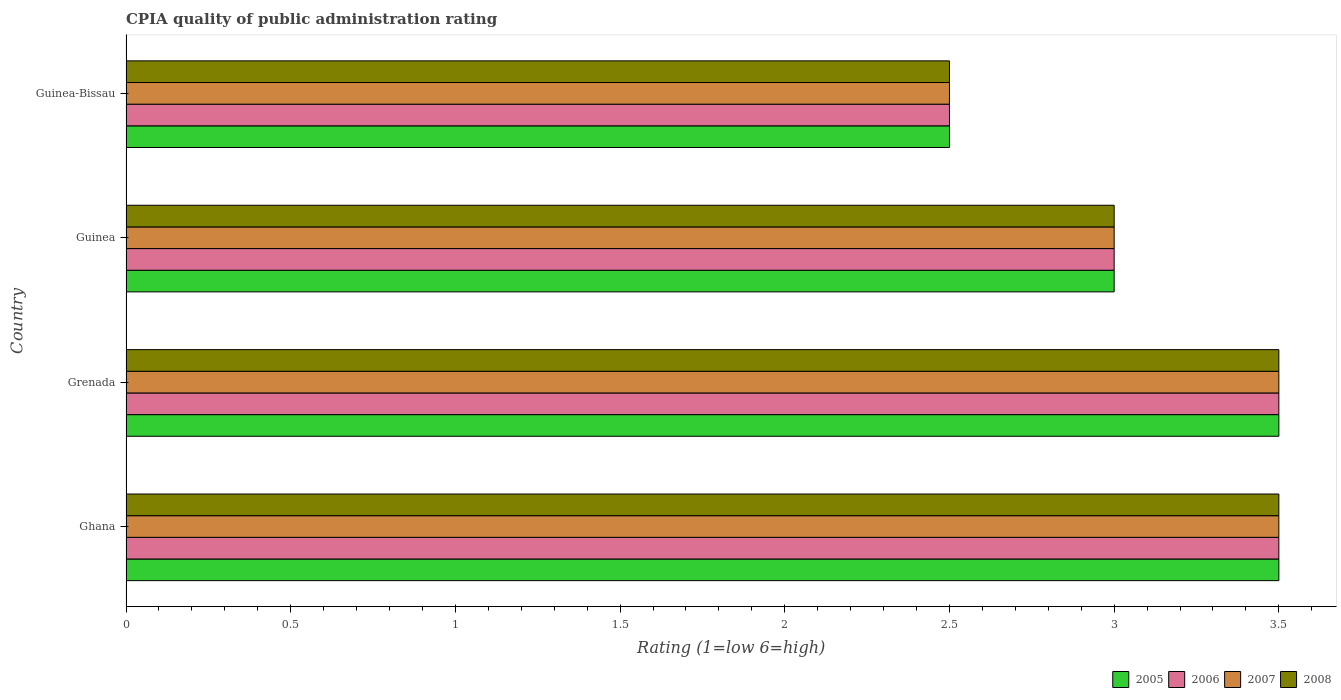How many different coloured bars are there?
Keep it short and to the point. 4. How many bars are there on the 3rd tick from the top?
Your response must be concise. 4. How many bars are there on the 2nd tick from the bottom?
Provide a short and direct response. 4. What is the label of the 1st group of bars from the top?
Ensure brevity in your answer.  Guinea-Bissau. In how many cases, is the number of bars for a given country not equal to the number of legend labels?
Your response must be concise. 0. Across all countries, what is the minimum CPIA rating in 2005?
Provide a short and direct response. 2.5. In which country was the CPIA rating in 2006 minimum?
Offer a terse response. Guinea-Bissau. What is the difference between the CPIA rating in 2005 in Guinea-Bissau and the CPIA rating in 2007 in Grenada?
Offer a terse response. -1. What is the average CPIA rating in 2005 per country?
Give a very brief answer. 3.12. What is the ratio of the CPIA rating in 2006 in Ghana to that in Guinea?
Your response must be concise. 1.17. Is the difference between the CPIA rating in 2007 in Ghana and Grenada greater than the difference between the CPIA rating in 2006 in Ghana and Grenada?
Offer a very short reply. No. What is the difference between the highest and the second highest CPIA rating in 2005?
Give a very brief answer. 0. What is the difference between the highest and the lowest CPIA rating in 2008?
Provide a succinct answer. 1. In how many countries, is the CPIA rating in 2008 greater than the average CPIA rating in 2008 taken over all countries?
Ensure brevity in your answer.  2. Is the sum of the CPIA rating in 2007 in Grenada and Guinea greater than the maximum CPIA rating in 2006 across all countries?
Give a very brief answer. Yes. Is it the case that in every country, the sum of the CPIA rating in 2008 and CPIA rating in 2007 is greater than the sum of CPIA rating in 2006 and CPIA rating in 2005?
Your response must be concise. No. What does the 2nd bar from the top in Guinea represents?
Your answer should be compact. 2007. How many bars are there?
Provide a short and direct response. 16. Are all the bars in the graph horizontal?
Ensure brevity in your answer.  Yes. Are the values on the major ticks of X-axis written in scientific E-notation?
Offer a terse response. No. Does the graph contain grids?
Your response must be concise. No. Where does the legend appear in the graph?
Your response must be concise. Bottom right. How are the legend labels stacked?
Your response must be concise. Horizontal. What is the title of the graph?
Ensure brevity in your answer.  CPIA quality of public administration rating. What is the Rating (1=low 6=high) in 2005 in Ghana?
Ensure brevity in your answer.  3.5. What is the Rating (1=low 6=high) in 2006 in Ghana?
Your response must be concise. 3.5. What is the Rating (1=low 6=high) of 2008 in Ghana?
Your answer should be compact. 3.5. What is the Rating (1=low 6=high) in 2005 in Grenada?
Give a very brief answer. 3.5. What is the Rating (1=low 6=high) of 2006 in Grenada?
Offer a terse response. 3.5. What is the Rating (1=low 6=high) in 2006 in Guinea?
Make the answer very short. 3. What is the Rating (1=low 6=high) in 2007 in Guinea?
Your answer should be compact. 3. What is the Rating (1=low 6=high) in 2008 in Guinea?
Your answer should be very brief. 3. What is the Rating (1=low 6=high) of 2005 in Guinea-Bissau?
Ensure brevity in your answer.  2.5. What is the Rating (1=low 6=high) in 2006 in Guinea-Bissau?
Keep it short and to the point. 2.5. What is the Rating (1=low 6=high) of 2007 in Guinea-Bissau?
Offer a terse response. 2.5. Across all countries, what is the maximum Rating (1=low 6=high) of 2005?
Your response must be concise. 3.5. Across all countries, what is the maximum Rating (1=low 6=high) in 2006?
Ensure brevity in your answer.  3.5. Across all countries, what is the maximum Rating (1=low 6=high) in 2008?
Make the answer very short. 3.5. Across all countries, what is the minimum Rating (1=low 6=high) of 2006?
Your answer should be very brief. 2.5. What is the total Rating (1=low 6=high) of 2006 in the graph?
Your response must be concise. 12.5. What is the total Rating (1=low 6=high) of 2008 in the graph?
Offer a terse response. 12.5. What is the difference between the Rating (1=low 6=high) in 2008 in Ghana and that in Grenada?
Keep it short and to the point. 0. What is the difference between the Rating (1=low 6=high) in 2005 in Ghana and that in Guinea?
Your response must be concise. 0.5. What is the difference between the Rating (1=low 6=high) in 2006 in Ghana and that in Guinea?
Make the answer very short. 0.5. What is the difference between the Rating (1=low 6=high) in 2008 in Ghana and that in Guinea?
Provide a short and direct response. 0.5. What is the difference between the Rating (1=low 6=high) of 2006 in Ghana and that in Guinea-Bissau?
Ensure brevity in your answer.  1. What is the difference between the Rating (1=low 6=high) in 2007 in Ghana and that in Guinea-Bissau?
Give a very brief answer. 1. What is the difference between the Rating (1=low 6=high) of 2006 in Grenada and that in Guinea?
Offer a very short reply. 0.5. What is the difference between the Rating (1=low 6=high) of 2005 in Grenada and that in Guinea-Bissau?
Provide a succinct answer. 1. What is the difference between the Rating (1=low 6=high) of 2006 in Grenada and that in Guinea-Bissau?
Provide a succinct answer. 1. What is the difference between the Rating (1=low 6=high) in 2008 in Grenada and that in Guinea-Bissau?
Provide a succinct answer. 1. What is the difference between the Rating (1=low 6=high) of 2005 in Guinea and that in Guinea-Bissau?
Your response must be concise. 0.5. What is the difference between the Rating (1=low 6=high) in 2007 in Guinea and that in Guinea-Bissau?
Offer a terse response. 0.5. What is the difference between the Rating (1=low 6=high) in 2008 in Guinea and that in Guinea-Bissau?
Offer a terse response. 0.5. What is the difference between the Rating (1=low 6=high) in 2005 in Ghana and the Rating (1=low 6=high) in 2006 in Grenada?
Provide a short and direct response. 0. What is the difference between the Rating (1=low 6=high) in 2005 in Ghana and the Rating (1=low 6=high) in 2007 in Grenada?
Make the answer very short. 0. What is the difference between the Rating (1=low 6=high) in 2005 in Ghana and the Rating (1=low 6=high) in 2008 in Grenada?
Give a very brief answer. 0. What is the difference between the Rating (1=low 6=high) in 2006 in Ghana and the Rating (1=low 6=high) in 2008 in Grenada?
Make the answer very short. 0. What is the difference between the Rating (1=low 6=high) in 2005 in Ghana and the Rating (1=low 6=high) in 2008 in Guinea-Bissau?
Make the answer very short. 1. What is the difference between the Rating (1=low 6=high) of 2005 in Grenada and the Rating (1=low 6=high) of 2006 in Guinea?
Offer a very short reply. 0.5. What is the difference between the Rating (1=low 6=high) in 2005 in Grenada and the Rating (1=low 6=high) in 2007 in Guinea?
Ensure brevity in your answer.  0.5. What is the difference between the Rating (1=low 6=high) of 2005 in Grenada and the Rating (1=low 6=high) of 2008 in Guinea?
Give a very brief answer. 0.5. What is the difference between the Rating (1=low 6=high) in 2006 in Grenada and the Rating (1=low 6=high) in 2007 in Guinea?
Provide a short and direct response. 0.5. What is the difference between the Rating (1=low 6=high) of 2005 in Grenada and the Rating (1=low 6=high) of 2006 in Guinea-Bissau?
Your answer should be compact. 1. What is the difference between the Rating (1=low 6=high) in 2005 in Grenada and the Rating (1=low 6=high) in 2007 in Guinea-Bissau?
Provide a short and direct response. 1. What is the difference between the Rating (1=low 6=high) of 2006 in Grenada and the Rating (1=low 6=high) of 2007 in Guinea-Bissau?
Keep it short and to the point. 1. What is the difference between the Rating (1=low 6=high) of 2005 in Guinea and the Rating (1=low 6=high) of 2007 in Guinea-Bissau?
Your answer should be compact. 0.5. What is the difference between the Rating (1=low 6=high) of 2005 in Guinea and the Rating (1=low 6=high) of 2008 in Guinea-Bissau?
Ensure brevity in your answer.  0.5. What is the difference between the Rating (1=low 6=high) of 2006 in Guinea and the Rating (1=low 6=high) of 2007 in Guinea-Bissau?
Ensure brevity in your answer.  0.5. What is the difference between the Rating (1=low 6=high) of 2007 in Guinea and the Rating (1=low 6=high) of 2008 in Guinea-Bissau?
Provide a short and direct response. 0.5. What is the average Rating (1=low 6=high) of 2005 per country?
Provide a succinct answer. 3.12. What is the average Rating (1=low 6=high) in 2006 per country?
Keep it short and to the point. 3.12. What is the average Rating (1=low 6=high) in 2007 per country?
Your answer should be very brief. 3.12. What is the average Rating (1=low 6=high) in 2008 per country?
Offer a very short reply. 3.12. What is the difference between the Rating (1=low 6=high) in 2005 and Rating (1=low 6=high) in 2006 in Ghana?
Your answer should be very brief. 0. What is the difference between the Rating (1=low 6=high) in 2006 and Rating (1=low 6=high) in 2007 in Ghana?
Offer a terse response. 0. What is the difference between the Rating (1=low 6=high) in 2006 and Rating (1=low 6=high) in 2008 in Ghana?
Your response must be concise. 0. What is the difference between the Rating (1=low 6=high) in 2005 and Rating (1=low 6=high) in 2007 in Grenada?
Your answer should be compact. 0. What is the difference between the Rating (1=low 6=high) of 2005 and Rating (1=low 6=high) of 2008 in Grenada?
Keep it short and to the point. 0. What is the difference between the Rating (1=low 6=high) of 2006 and Rating (1=low 6=high) of 2007 in Grenada?
Your response must be concise. 0. What is the difference between the Rating (1=low 6=high) of 2005 and Rating (1=low 6=high) of 2006 in Guinea?
Your response must be concise. 0. What is the difference between the Rating (1=low 6=high) of 2005 and Rating (1=low 6=high) of 2007 in Guinea?
Make the answer very short. 0. What is the difference between the Rating (1=low 6=high) in 2005 and Rating (1=low 6=high) in 2008 in Guinea?
Keep it short and to the point. 0. What is the difference between the Rating (1=low 6=high) in 2005 and Rating (1=low 6=high) in 2007 in Guinea-Bissau?
Provide a succinct answer. 0. What is the difference between the Rating (1=low 6=high) of 2006 and Rating (1=low 6=high) of 2008 in Guinea-Bissau?
Keep it short and to the point. 0. What is the difference between the Rating (1=low 6=high) in 2007 and Rating (1=low 6=high) in 2008 in Guinea-Bissau?
Offer a very short reply. 0. What is the ratio of the Rating (1=low 6=high) of 2005 in Ghana to that in Grenada?
Make the answer very short. 1. What is the ratio of the Rating (1=low 6=high) in 2007 in Ghana to that in Guinea?
Your response must be concise. 1.17. What is the ratio of the Rating (1=low 6=high) in 2008 in Ghana to that in Guinea?
Provide a short and direct response. 1.17. What is the ratio of the Rating (1=low 6=high) in 2005 in Ghana to that in Guinea-Bissau?
Keep it short and to the point. 1.4. What is the ratio of the Rating (1=low 6=high) of 2007 in Ghana to that in Guinea-Bissau?
Give a very brief answer. 1.4. What is the ratio of the Rating (1=low 6=high) of 2006 in Grenada to that in Guinea?
Provide a short and direct response. 1.17. What is the ratio of the Rating (1=low 6=high) in 2007 in Grenada to that in Guinea?
Keep it short and to the point. 1.17. What is the ratio of the Rating (1=low 6=high) in 2007 in Grenada to that in Guinea-Bissau?
Give a very brief answer. 1.4. What is the ratio of the Rating (1=low 6=high) of 2006 in Guinea to that in Guinea-Bissau?
Offer a very short reply. 1.2. What is the ratio of the Rating (1=low 6=high) in 2008 in Guinea to that in Guinea-Bissau?
Make the answer very short. 1.2. What is the difference between the highest and the second highest Rating (1=low 6=high) in 2006?
Your answer should be very brief. 0. What is the difference between the highest and the second highest Rating (1=low 6=high) in 2007?
Make the answer very short. 0. What is the difference between the highest and the second highest Rating (1=low 6=high) of 2008?
Your response must be concise. 0. What is the difference between the highest and the lowest Rating (1=low 6=high) of 2005?
Your answer should be compact. 1. What is the difference between the highest and the lowest Rating (1=low 6=high) in 2006?
Ensure brevity in your answer.  1. 